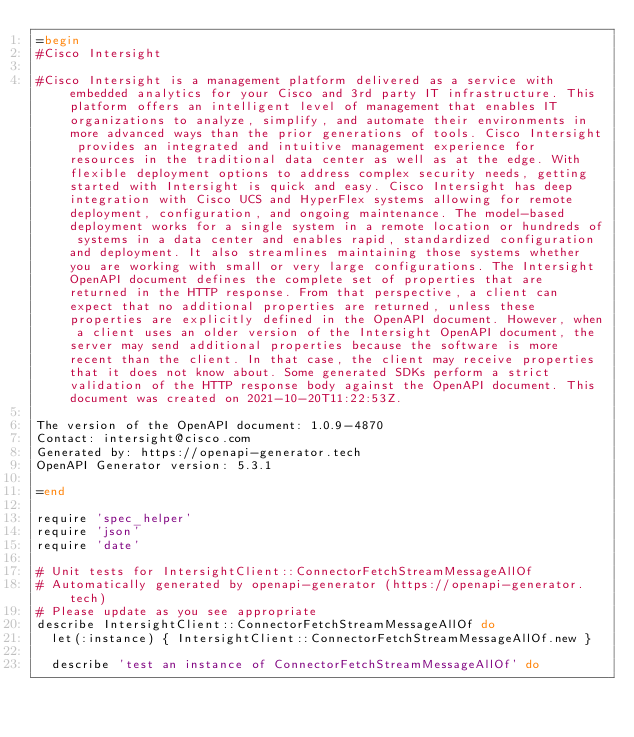Convert code to text. <code><loc_0><loc_0><loc_500><loc_500><_Ruby_>=begin
#Cisco Intersight

#Cisco Intersight is a management platform delivered as a service with embedded analytics for your Cisco and 3rd party IT infrastructure. This platform offers an intelligent level of management that enables IT organizations to analyze, simplify, and automate their environments in more advanced ways than the prior generations of tools. Cisco Intersight provides an integrated and intuitive management experience for resources in the traditional data center as well as at the edge. With flexible deployment options to address complex security needs, getting started with Intersight is quick and easy. Cisco Intersight has deep integration with Cisco UCS and HyperFlex systems allowing for remote deployment, configuration, and ongoing maintenance. The model-based deployment works for a single system in a remote location or hundreds of systems in a data center and enables rapid, standardized configuration and deployment. It also streamlines maintaining those systems whether you are working with small or very large configurations. The Intersight OpenAPI document defines the complete set of properties that are returned in the HTTP response. From that perspective, a client can expect that no additional properties are returned, unless these properties are explicitly defined in the OpenAPI document. However, when a client uses an older version of the Intersight OpenAPI document, the server may send additional properties because the software is more recent than the client. In that case, the client may receive properties that it does not know about. Some generated SDKs perform a strict validation of the HTTP response body against the OpenAPI document. This document was created on 2021-10-20T11:22:53Z.

The version of the OpenAPI document: 1.0.9-4870
Contact: intersight@cisco.com
Generated by: https://openapi-generator.tech
OpenAPI Generator version: 5.3.1

=end

require 'spec_helper'
require 'json'
require 'date'

# Unit tests for IntersightClient::ConnectorFetchStreamMessageAllOf
# Automatically generated by openapi-generator (https://openapi-generator.tech)
# Please update as you see appropriate
describe IntersightClient::ConnectorFetchStreamMessageAllOf do
  let(:instance) { IntersightClient::ConnectorFetchStreamMessageAllOf.new }

  describe 'test an instance of ConnectorFetchStreamMessageAllOf' do</code> 